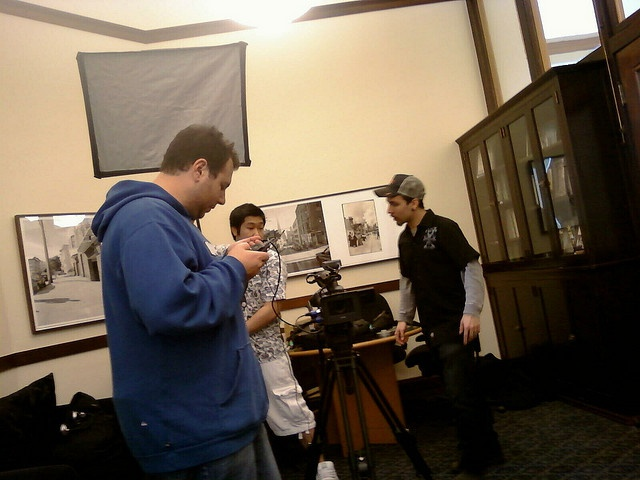Describe the objects in this image and their specific colors. I can see people in gray, black, navy, and darkblue tones, people in gray, black, and maroon tones, couch in gray, black, and darkgray tones, people in gray, darkgray, and black tones, and dining table in gray, black, maroon, and olive tones in this image. 